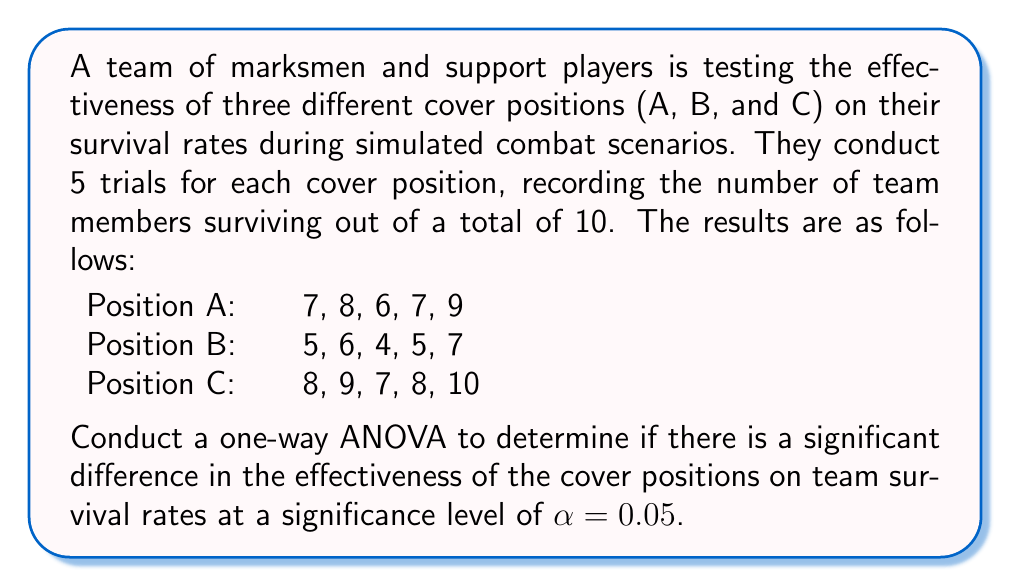Could you help me with this problem? To conduct a one-way ANOVA, we'll follow these steps:

1. Calculate the sum of squares between groups (SSB), within groups (SSW), and total (SST).
2. Calculate the degrees of freedom for between groups (dfB), within groups (dfW), and total (dfT).
3. Calculate the mean squares between groups (MSB) and within groups (MSW).
4. Calculate the F-statistic.
5. Compare the F-statistic to the critical F-value.

Step 1: Calculate sum of squares

First, we need to calculate the grand mean:
$\bar{X} = \frac{7+8+6+7+9+5+6+4+5+7+8+9+7+8+10}{15} = 7.07$

Now, we can calculate SSB, SSW, and SST:

SSB = $n\sum_{i=1}^k(\bar{X_i} - \bar{X})^2$
    = $5[(7.4 - 7.07)^2 + (5.4 - 7.07)^2 + (8.4 - 7.07)^2]$
    = $5[0.11 + 2.79 + 1.77]$
    = $23.35$

SSW = $\sum_{i=1}^k\sum_{j=1}^n(X_{ij} - \bar{X_i})^2$
    = $[(7-7.4)^2 + (8-7.4)^2 + (6-7.4)^2 + (7-7.4)^2 + (9-7.4)^2]$
    + $[(5-5.4)^2 + (6-5.4)^2 + (4-5.4)^2 + (5-5.4)^2 + (7-5.4)^2]$
    + $[(8-8.4)^2 + (9-8.4)^2 + (7-8.4)^2 + (8-8.4)^2 + (10-8.4)^2]$
    = $5.2 + 5.2 + 5.2 = 15.6$

SST = SSB + SSW = $23.35 + 15.6 = 38.95$

Step 2: Calculate degrees of freedom

dfB = $k - 1 = 3 - 1 = 2$
dfW = $N - k = 15 - 3 = 12$
dfT = $N - 1 = 15 - 1 = 14$

Step 3: Calculate mean squares

MSB = $\frac{SSB}{dfB} = \frac{23.35}{2} = 11.675$
MSW = $\frac{SSW}{dfW} = \frac{15.6}{12} = 1.3$

Step 4: Calculate F-statistic

$F = \frac{MSB}{MSW} = \frac{11.675}{1.3} = 8.98$

Step 5: Compare F-statistic to critical F-value

The critical F-value for $\alpha = 0.05$, dfB = 2, and dfW = 12 is approximately 3.89.

Since our calculated F-statistic (8.98) is greater than the critical F-value (3.89), we reject the null hypothesis.
Answer: Reject the null hypothesis. There is a significant difference in the effectiveness of the cover positions on team survival rates at a significance level of $\alpha = 0.05$. The F-statistic (8.98) is greater than the critical F-value (3.89), indicating that at least one of the cover positions has a significantly different effect on team survival rates compared to the others. 